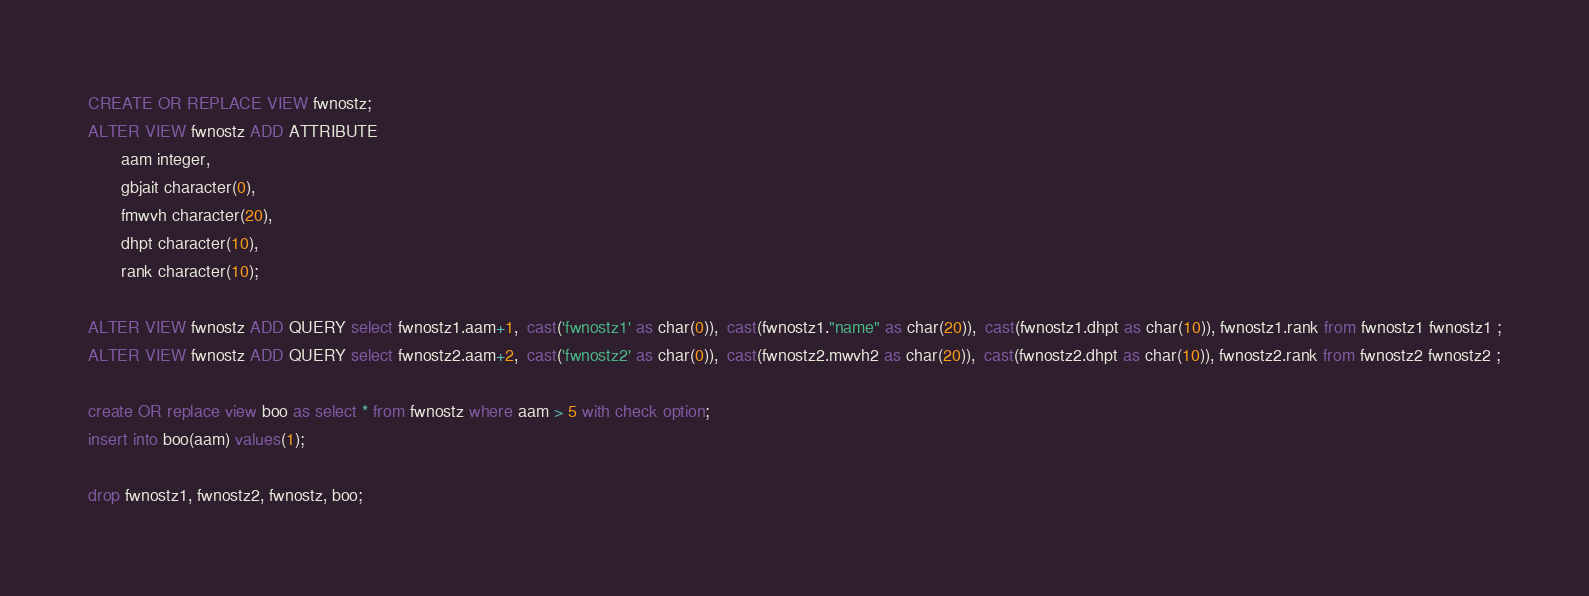<code> <loc_0><loc_0><loc_500><loc_500><_SQL_>
CREATE OR REPLACE VIEW fwnostz;
ALTER VIEW fwnostz ADD ATTRIBUTE
       aam integer,
       gbjait character(0),
       fmwvh character(20),
       dhpt character(10),
       rank character(10);

ALTER VIEW fwnostz ADD QUERY select fwnostz1.aam+1,  cast('fwnostz1' as char(0)),  cast(fwnostz1."name" as char(20)),  cast(fwnostz1.dhpt as char(10)), fwnostz1.rank from fwnostz1 fwnostz1 ;
ALTER VIEW fwnostz ADD QUERY select fwnostz2.aam+2,  cast('fwnostz2' as char(0)),  cast(fwnostz2.mwvh2 as char(20)),  cast(fwnostz2.dhpt as char(10)), fwnostz2.rank from fwnostz2 fwnostz2 ;

create OR replace view boo as select * from fwnostz where aam > 5 with check option;
insert into boo(aam) values(1);

drop fwnostz1, fwnostz2, fwnostz, boo;
</code> 